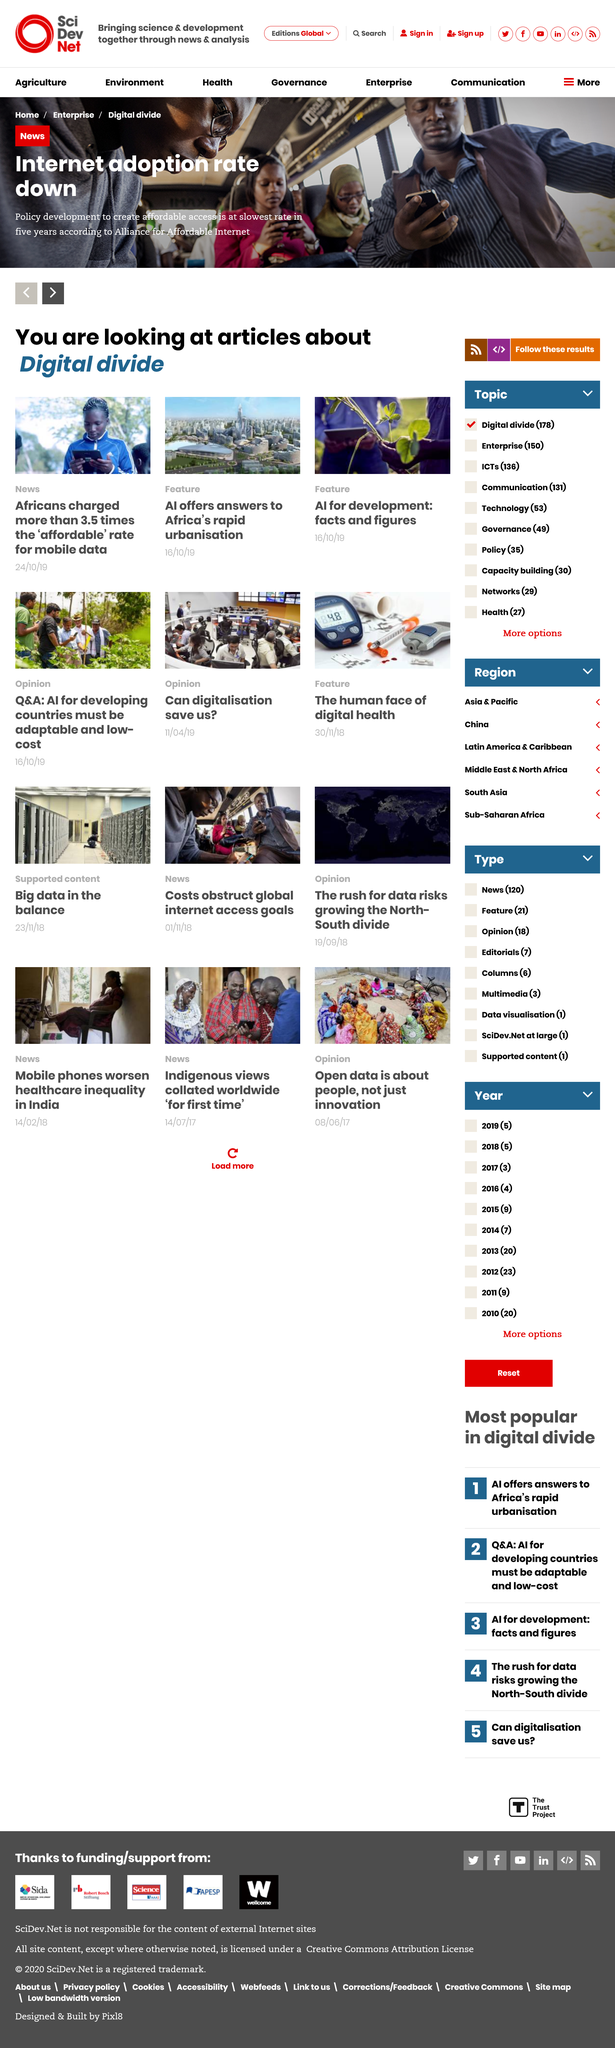Outline some significant characteristics in this image. The article titled "AI offers answers to Africa's rapid urbanisation" published on 16/10/19 provides insight into how artificial intelligence is helping to address the challenges of urbanization in Africa. African consumers are charged more than three and a half times the affordable rate for mobile data. The adoption rate of the internet has decreased. 